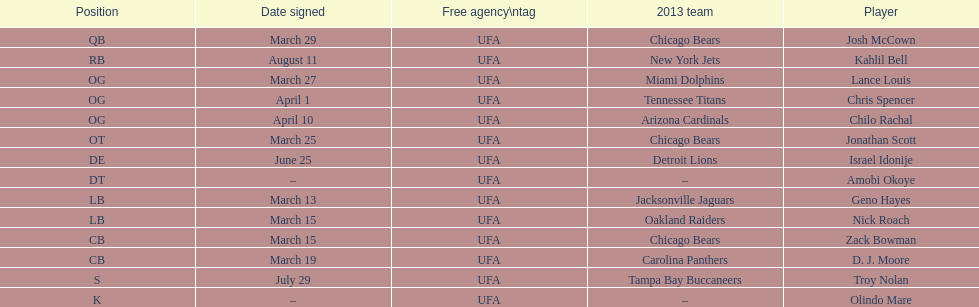What is the total of 2013 teams on the chart? 10. 